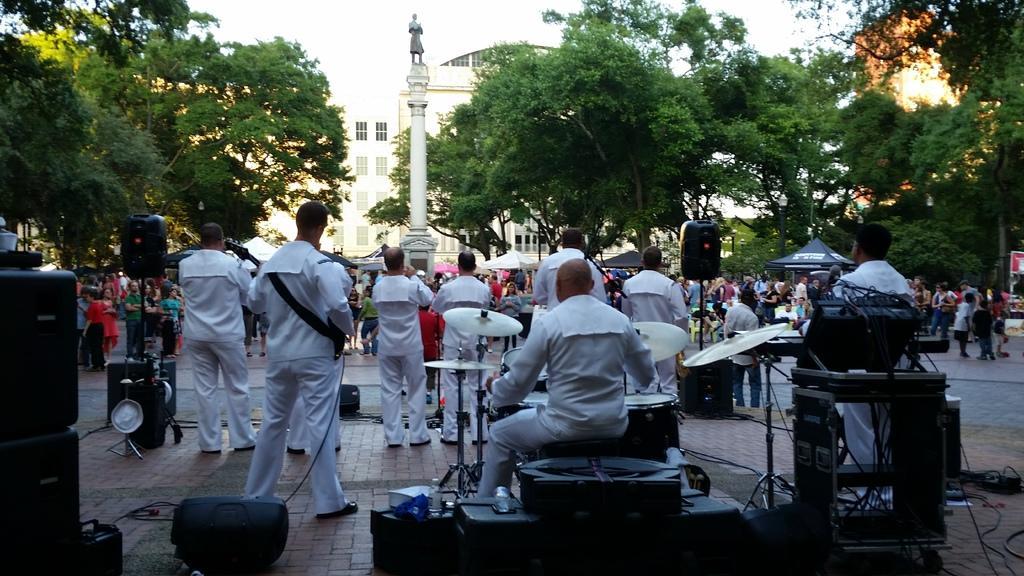How would you summarize this image in a sentence or two? There is a group of a people. In this picture outside of the city. some people are standing and some people are sitting in a chair. We can see in the background there is a trees ,sky and road. On the left side we have a person's. They are wearing colorful white shirts. In the center we have a another person. His playing guitar. In the center we have another person is also playing guitar. 